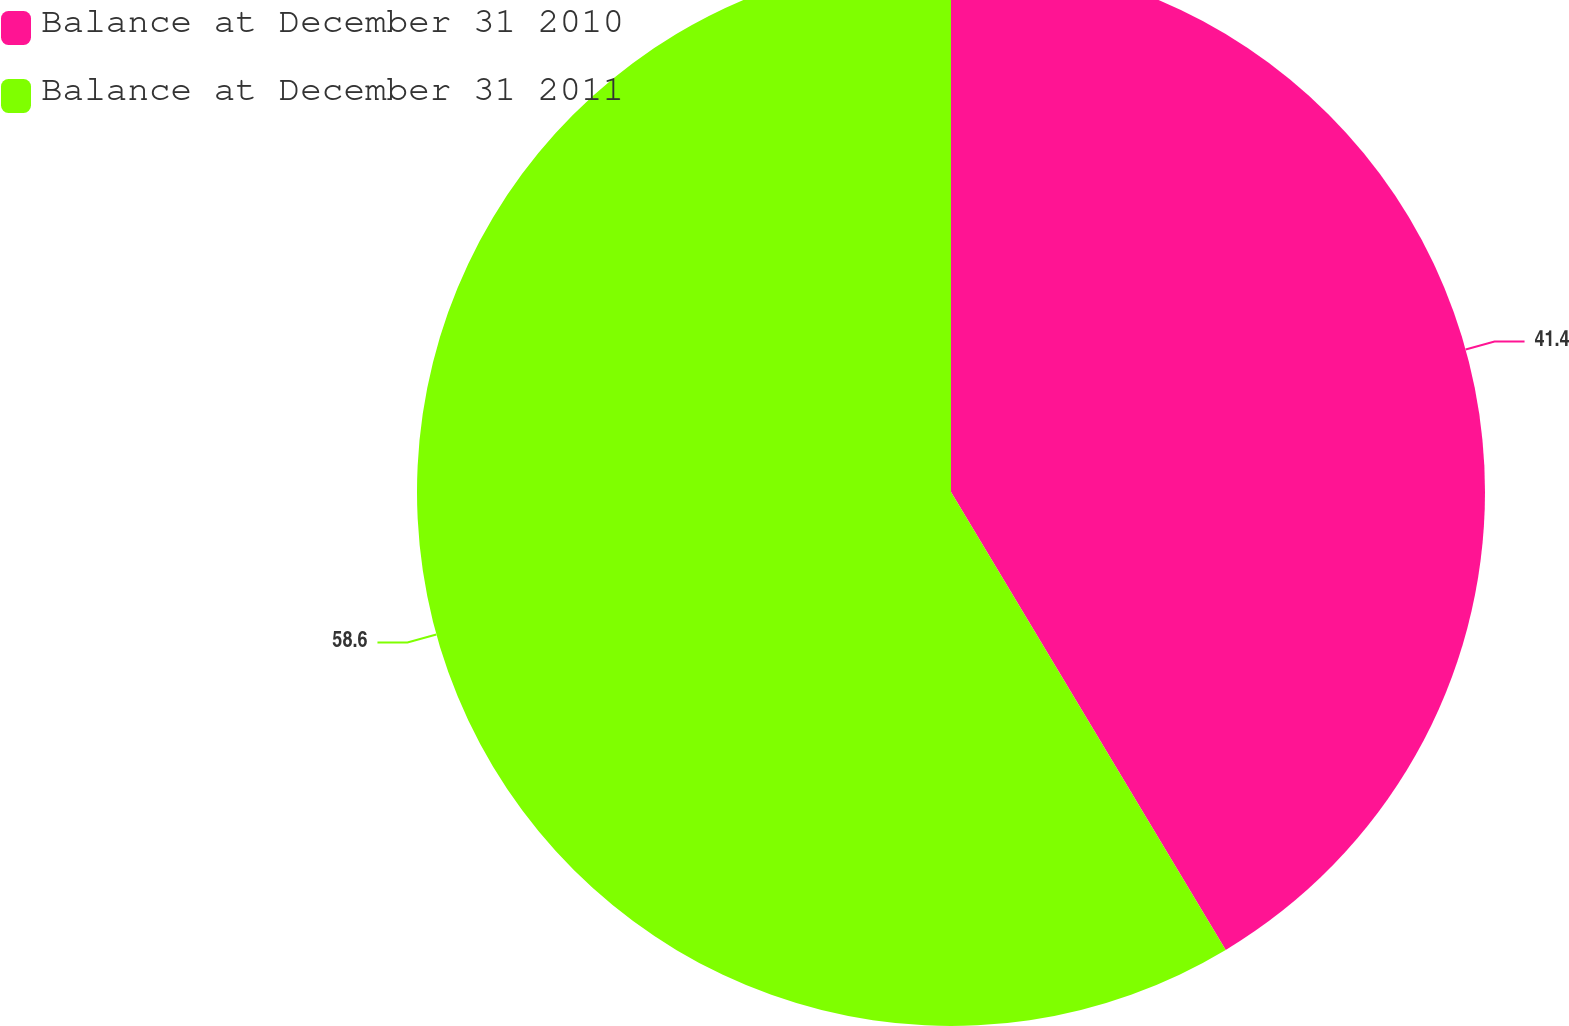<chart> <loc_0><loc_0><loc_500><loc_500><pie_chart><fcel>Balance at December 31 2010<fcel>Balance at December 31 2011<nl><fcel>41.4%<fcel>58.6%<nl></chart> 